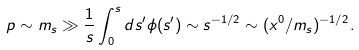<formula> <loc_0><loc_0><loc_500><loc_500>p \sim m _ { s } \gg \frac { 1 } { s } \int _ { 0 } ^ { s } d s ^ { \prime } \phi ( s ^ { \prime } ) \sim s ^ { - 1 / 2 } \sim ( x ^ { 0 } / m _ { s } ) ^ { - 1 / 2 } .</formula> 